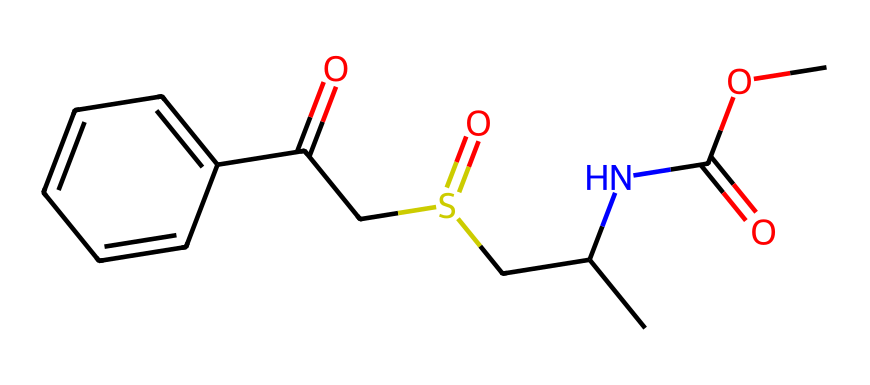What is the molecular formula of modafinil? To determine the molecular formula, we analyze the SMILES representation and count the number of each type of atom present. Carbon (C), Hydrogen (H), Nitrogen (N), and Oxygen (O) atoms can be identified through their symbols. In total, the count is: C = 15, H = 15, N = 1, O = 3, S = 1. Thus, the molecular formula is C15H15NO3S.
Answer: C15H15NO3S How many rings are present in the modafinil structure? Examining the SMILES representation reveals that the compound includes a six-membered aromatic ring denoted by 'C1=CC=C(C=C1)'. This indicates there is one ring in the structure.
Answer: 1 What functional groups are present in modafinil? The SMILES indicates the presence of a sulfonamide group (due to 'S(=O)'), a carbonyl group (from 'C(=O)'), and an ester (indicated by 'C(=O)O'). By identifying these specific features, we conclude the functional groups present.
Answer: sulfonamide, carbonyl, ester What is the oxidation state of sulfur in modafinil? To find the oxidation state of sulfur, we identify its bonds and count the electrons. In the SMILES, sulfur is attached to two oxygen atoms (one double bond and one single bond) and one carbon chain. The formal oxidation state can be calculated as follows: Sulfur typically has an oxidation state of +6 when bonded to two oxygens and one alkyl group in this arrangement. Thus, the oxidation state is +6.
Answer: +6 What type of compound is modafinil classified as? Modafinil is best described under the category of "cognitive enhancers" or "nootropics," as indicated by its structure and pharmacological application, characterized by its ability to enhance cognitive functions.
Answer: nootropic 